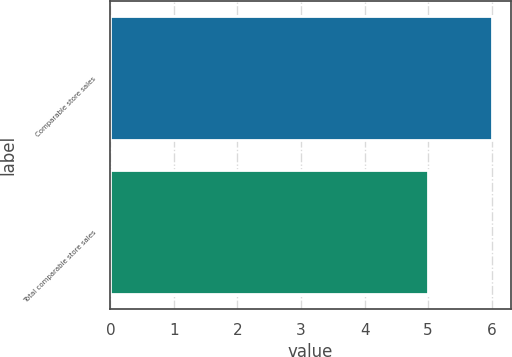Convert chart to OTSL. <chart><loc_0><loc_0><loc_500><loc_500><bar_chart><fcel>Comparable store sales<fcel>Total comparable store sales<nl><fcel>6<fcel>5<nl></chart> 